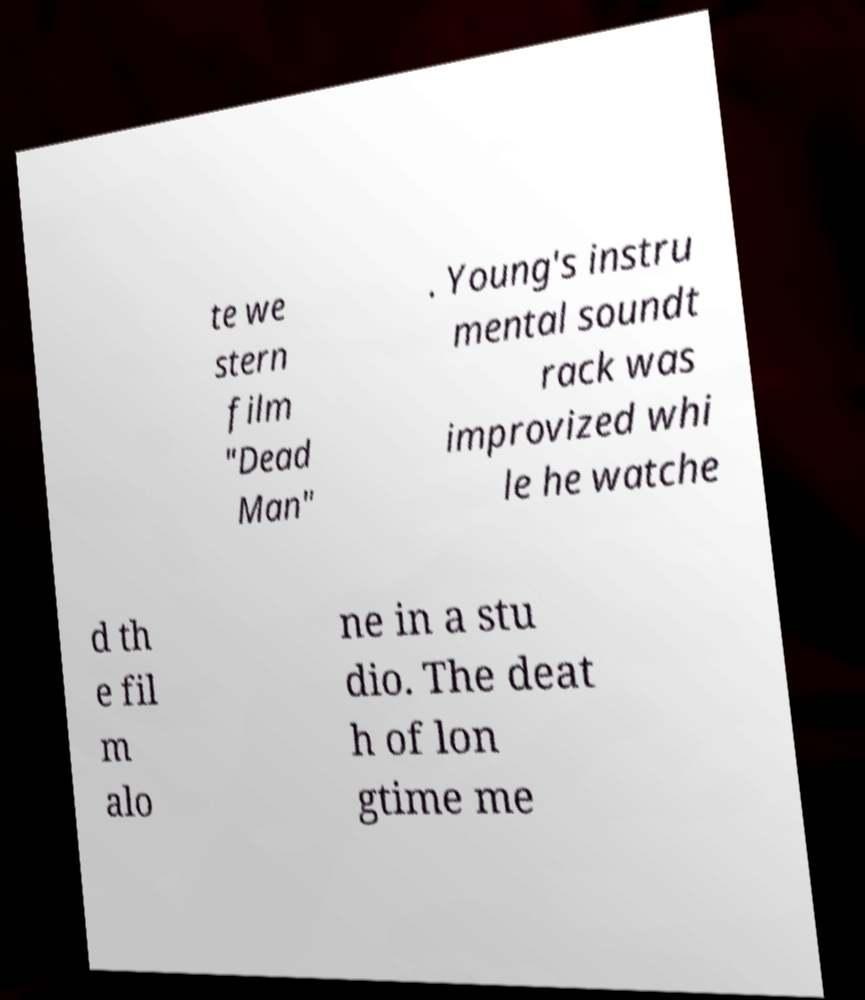For documentation purposes, I need the text within this image transcribed. Could you provide that? te we stern film "Dead Man" . Young's instru mental soundt rack was improvized whi le he watche d th e fil m alo ne in a stu dio. The deat h of lon gtime me 